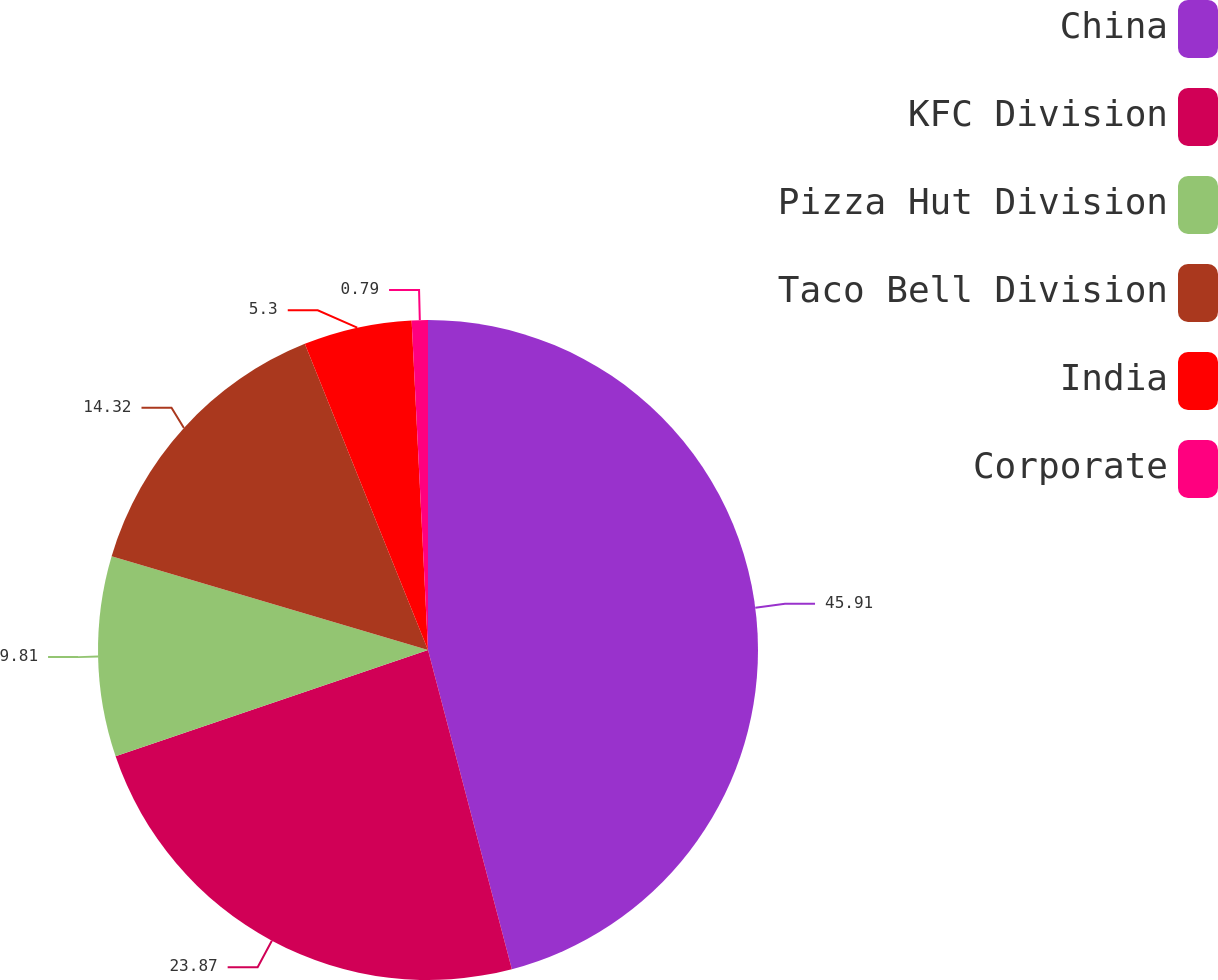<chart> <loc_0><loc_0><loc_500><loc_500><pie_chart><fcel>China<fcel>KFC Division<fcel>Pizza Hut Division<fcel>Taco Bell Division<fcel>India<fcel>Corporate<nl><fcel>45.91%<fcel>23.87%<fcel>9.81%<fcel>14.32%<fcel>5.3%<fcel>0.79%<nl></chart> 